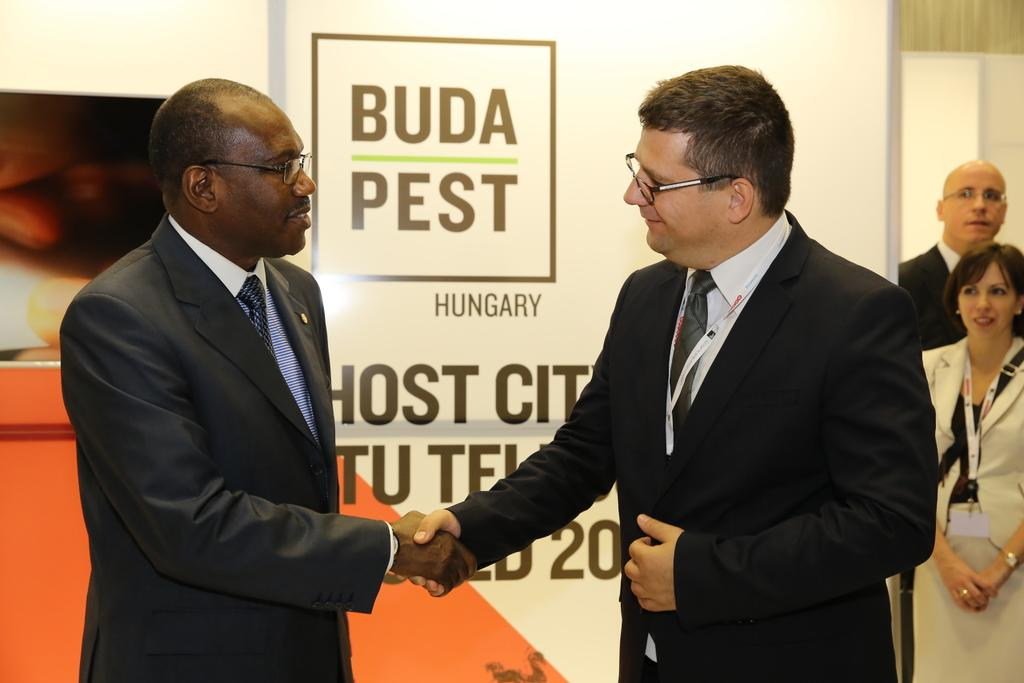How many people are in the foreground of the image? There are two men in the foreground of the image. What are the two men doing in the image? The two men are greeting each other. What can be seen in the background of the image? There is some text on a surface in the background of the image. How many other people are visible in the image? There are two other people on the right side of the image. What color is the son's eye in the image? There is no son or eye present in the image. What is the front of the image showing? The front of the image shows the two men greeting each other in the foreground and some text in the background. 